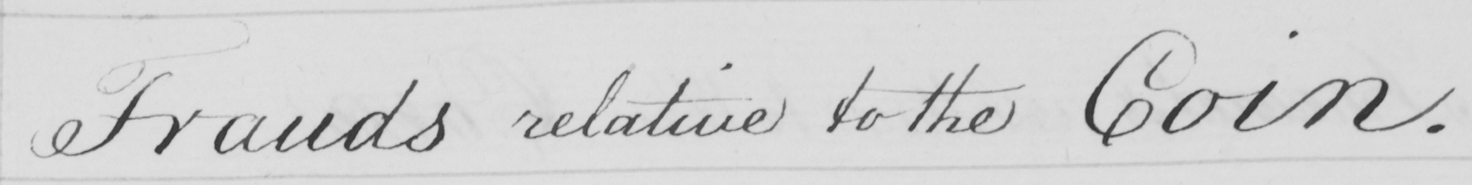What text is written in this handwritten line? Frauds relative to the Coin . 